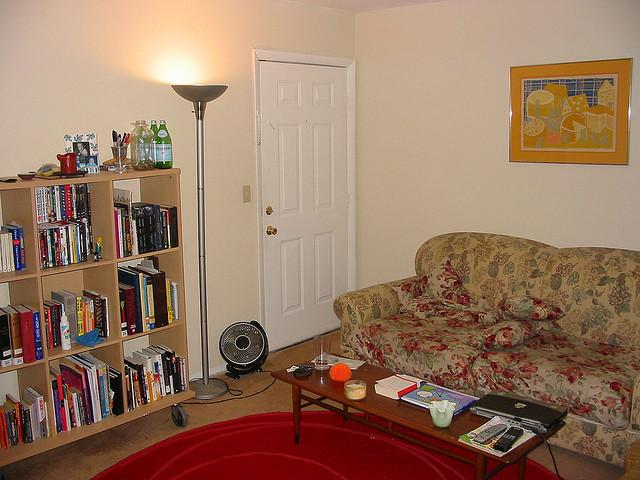Which electronic device is likely located in front of the coffee table?

Choices:
A) television
B) record player
C) telephone
D) stereo television 